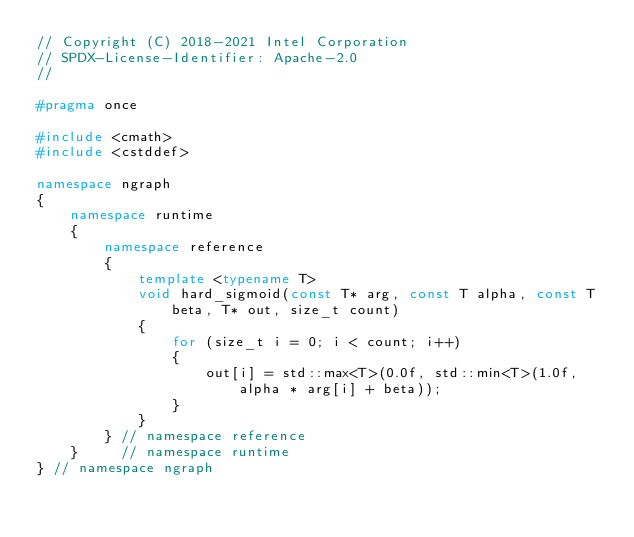<code> <loc_0><loc_0><loc_500><loc_500><_C++_>// Copyright (C) 2018-2021 Intel Corporation
// SPDX-License-Identifier: Apache-2.0
//

#pragma once

#include <cmath>
#include <cstddef>

namespace ngraph
{
    namespace runtime
    {
        namespace reference
        {
            template <typename T>
            void hard_sigmoid(const T* arg, const T alpha, const T beta, T* out, size_t count)
            {
                for (size_t i = 0; i < count; i++)
                {
                    out[i] = std::max<T>(0.0f, std::min<T>(1.0f, alpha * arg[i] + beta));
                }
            }
        } // namespace reference
    }     // namespace runtime
} // namespace ngraph
</code> 